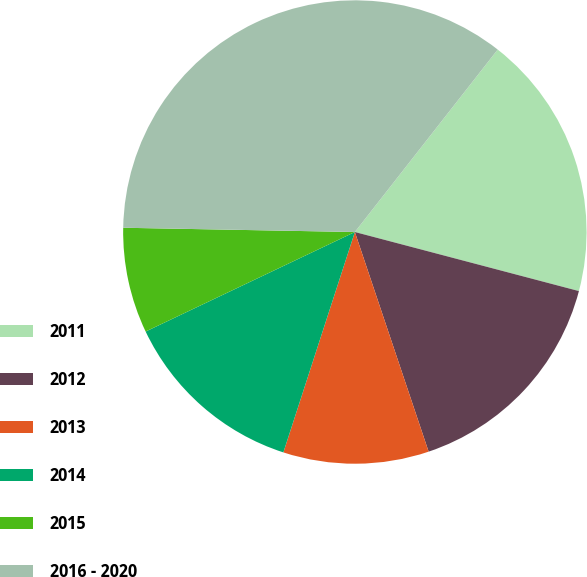Convert chart. <chart><loc_0><loc_0><loc_500><loc_500><pie_chart><fcel>2011<fcel>2012<fcel>2013<fcel>2014<fcel>2015<fcel>2016 - 2020<nl><fcel>18.53%<fcel>15.74%<fcel>10.15%<fcel>12.94%<fcel>7.36%<fcel>35.28%<nl></chart> 